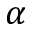<formula> <loc_0><loc_0><loc_500><loc_500>\alpha</formula> 